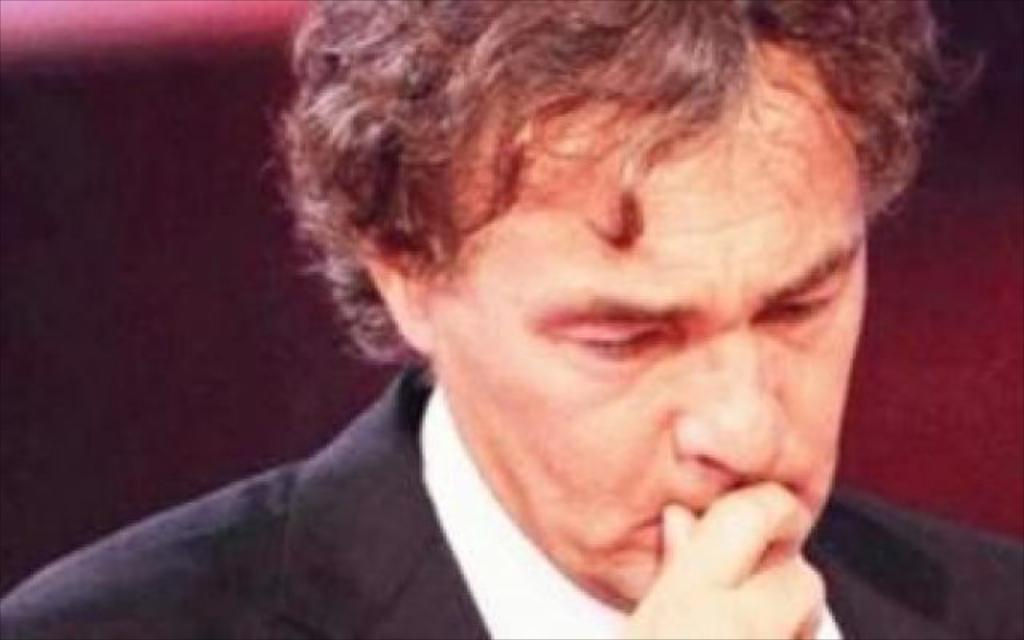What is the main subject in the foreground of the image? There is a person in the foreground of the image. Can you describe the background of the image? The background of the image is blurred. What type of distribution system is visible in the image? There is no distribution system present in the image; it features a person in the foreground and a blurred background. Can you see any fangs or fang-like structures in the image? There are no fangs or fang-like structures present in the image. 